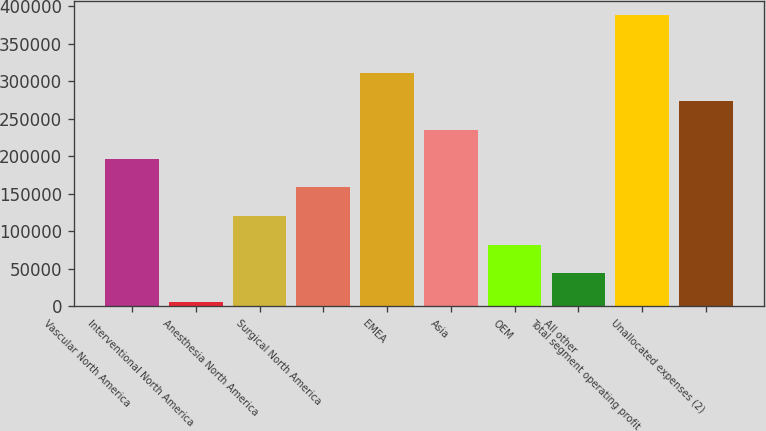Convert chart to OTSL. <chart><loc_0><loc_0><loc_500><loc_500><bar_chart><fcel>Vascular North America<fcel>Interventional North America<fcel>Anesthesia North America<fcel>Surgical North America<fcel>EMEA<fcel>Asia<fcel>OEM<fcel>All other<fcel>Total segment operating profit<fcel>Unallocated expenses (2)<nl><fcel>196828<fcel>5800<fcel>120416<fcel>158622<fcel>311444<fcel>235033<fcel>82211<fcel>44005.5<fcel>387855<fcel>273238<nl></chart> 